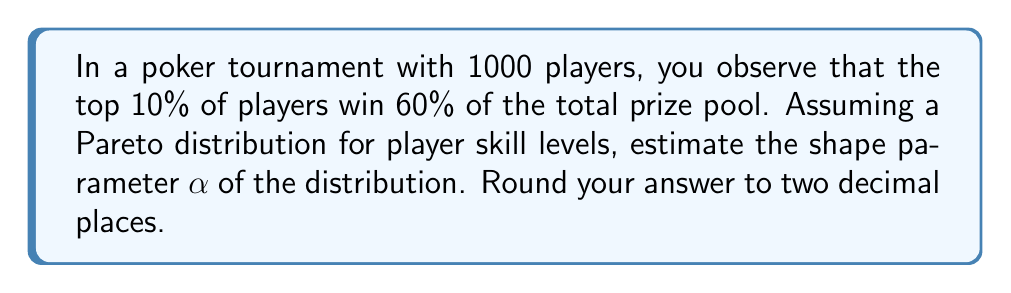What is the answer to this math problem? To solve this problem, we'll use the properties of the Pareto distribution and the given information about prize distribution.

1) The Pareto distribution is often used to model phenomena where a small percentage of the population accounts for a large percentage of the outcome. This fits well with the scenario described in the question.

2) For a Pareto distribution, the following relationship holds:

   $$ \frac{\text{Top } x\% \text{ of population}}{\text{Percentage of outcome they account for}} = x^{\frac{\alpha - 1}{\alpha}} $$

3) In our case:
   - Top $x\% = 10\% = 0.1$
   - Percentage of outcome = $60\% = 0.6$

4) Substituting these values into the equation:

   $$ \frac{0.1}{0.6} = 0.1^{\frac{\alpha - 1}{\alpha}} $$

5) Simplify the left side:

   $$ \frac{1}{6} = 0.1^{\frac{\alpha - 1}{\alpha}} $$

6) Take the natural log of both sides:

   $$ \ln(\frac{1}{6}) = \ln(0.1^{\frac{\alpha - 1}{\alpha}}) $$

7) Use the properties of logarithms:

   $$ \ln(\frac{1}{6}) = \frac{\alpha - 1}{\alpha} \ln(0.1) $$

8) Substitute the values:

   $$ -1.7918 = \frac{\alpha - 1}{\alpha} (-2.3026) $$

9) Solve for $\alpha$:

   $$ \alpha = \frac{2.3026}{2.3026 - 1.7918} \approx 4.4986 $$

10) Rounding to two decimal places:

    $$ \alpha \approx 4.50 $$
Answer: 4.50 